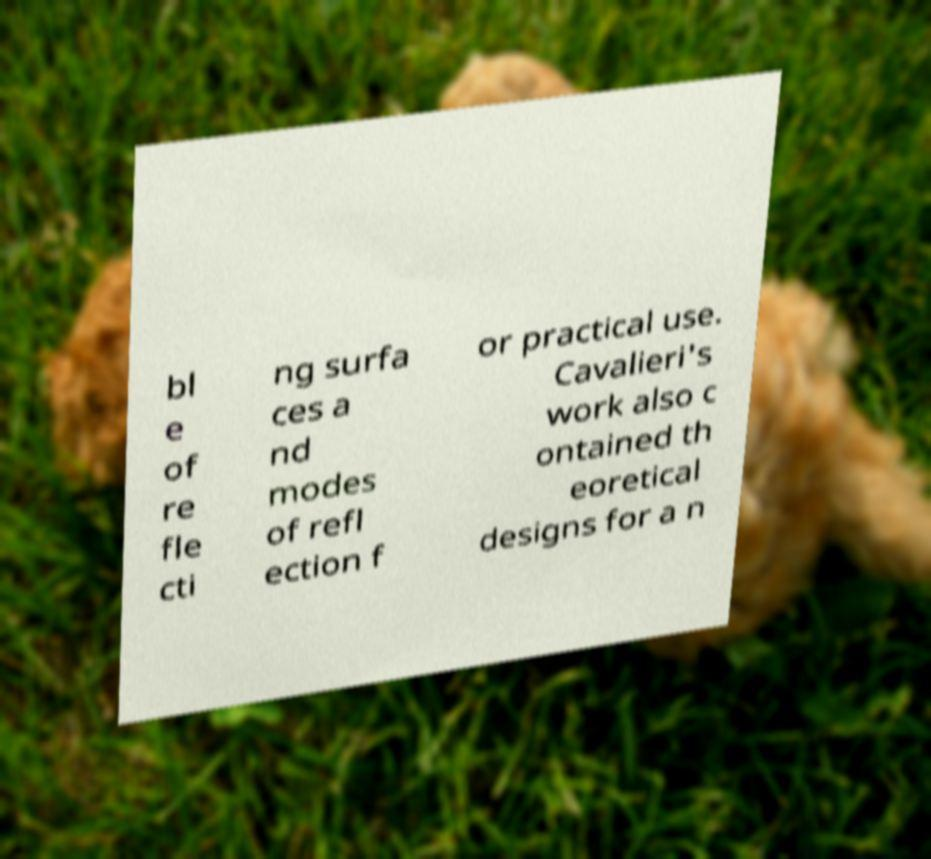Could you extract and type out the text from this image? bl e of re fle cti ng surfa ces a nd modes of refl ection f or practical use. Cavalieri's work also c ontained th eoretical designs for a n 